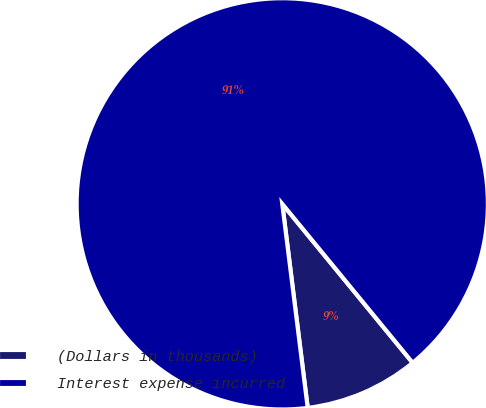<chart> <loc_0><loc_0><loc_500><loc_500><pie_chart><fcel>(Dollars in thousands)<fcel>Interest expense incurred<nl><fcel>8.96%<fcel>91.04%<nl></chart> 